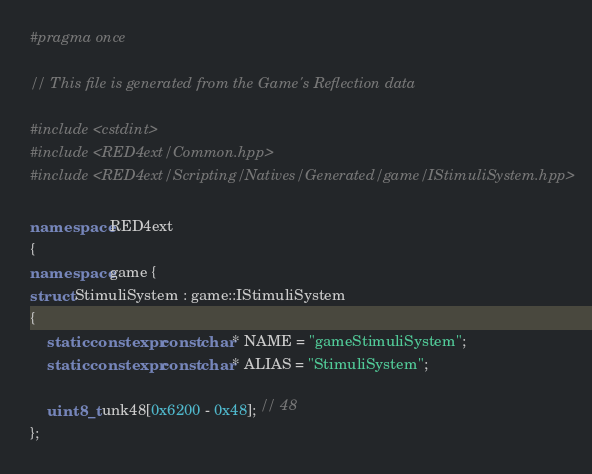Convert code to text. <code><loc_0><loc_0><loc_500><loc_500><_C++_>#pragma once

// This file is generated from the Game's Reflection data

#include <cstdint>
#include <RED4ext/Common.hpp>
#include <RED4ext/Scripting/Natives/Generated/game/IStimuliSystem.hpp>

namespace RED4ext
{
namespace game { 
struct StimuliSystem : game::IStimuliSystem
{
    static constexpr const char* NAME = "gameStimuliSystem";
    static constexpr const char* ALIAS = "StimuliSystem";

    uint8_t unk48[0x6200 - 0x48]; // 48
};</code> 